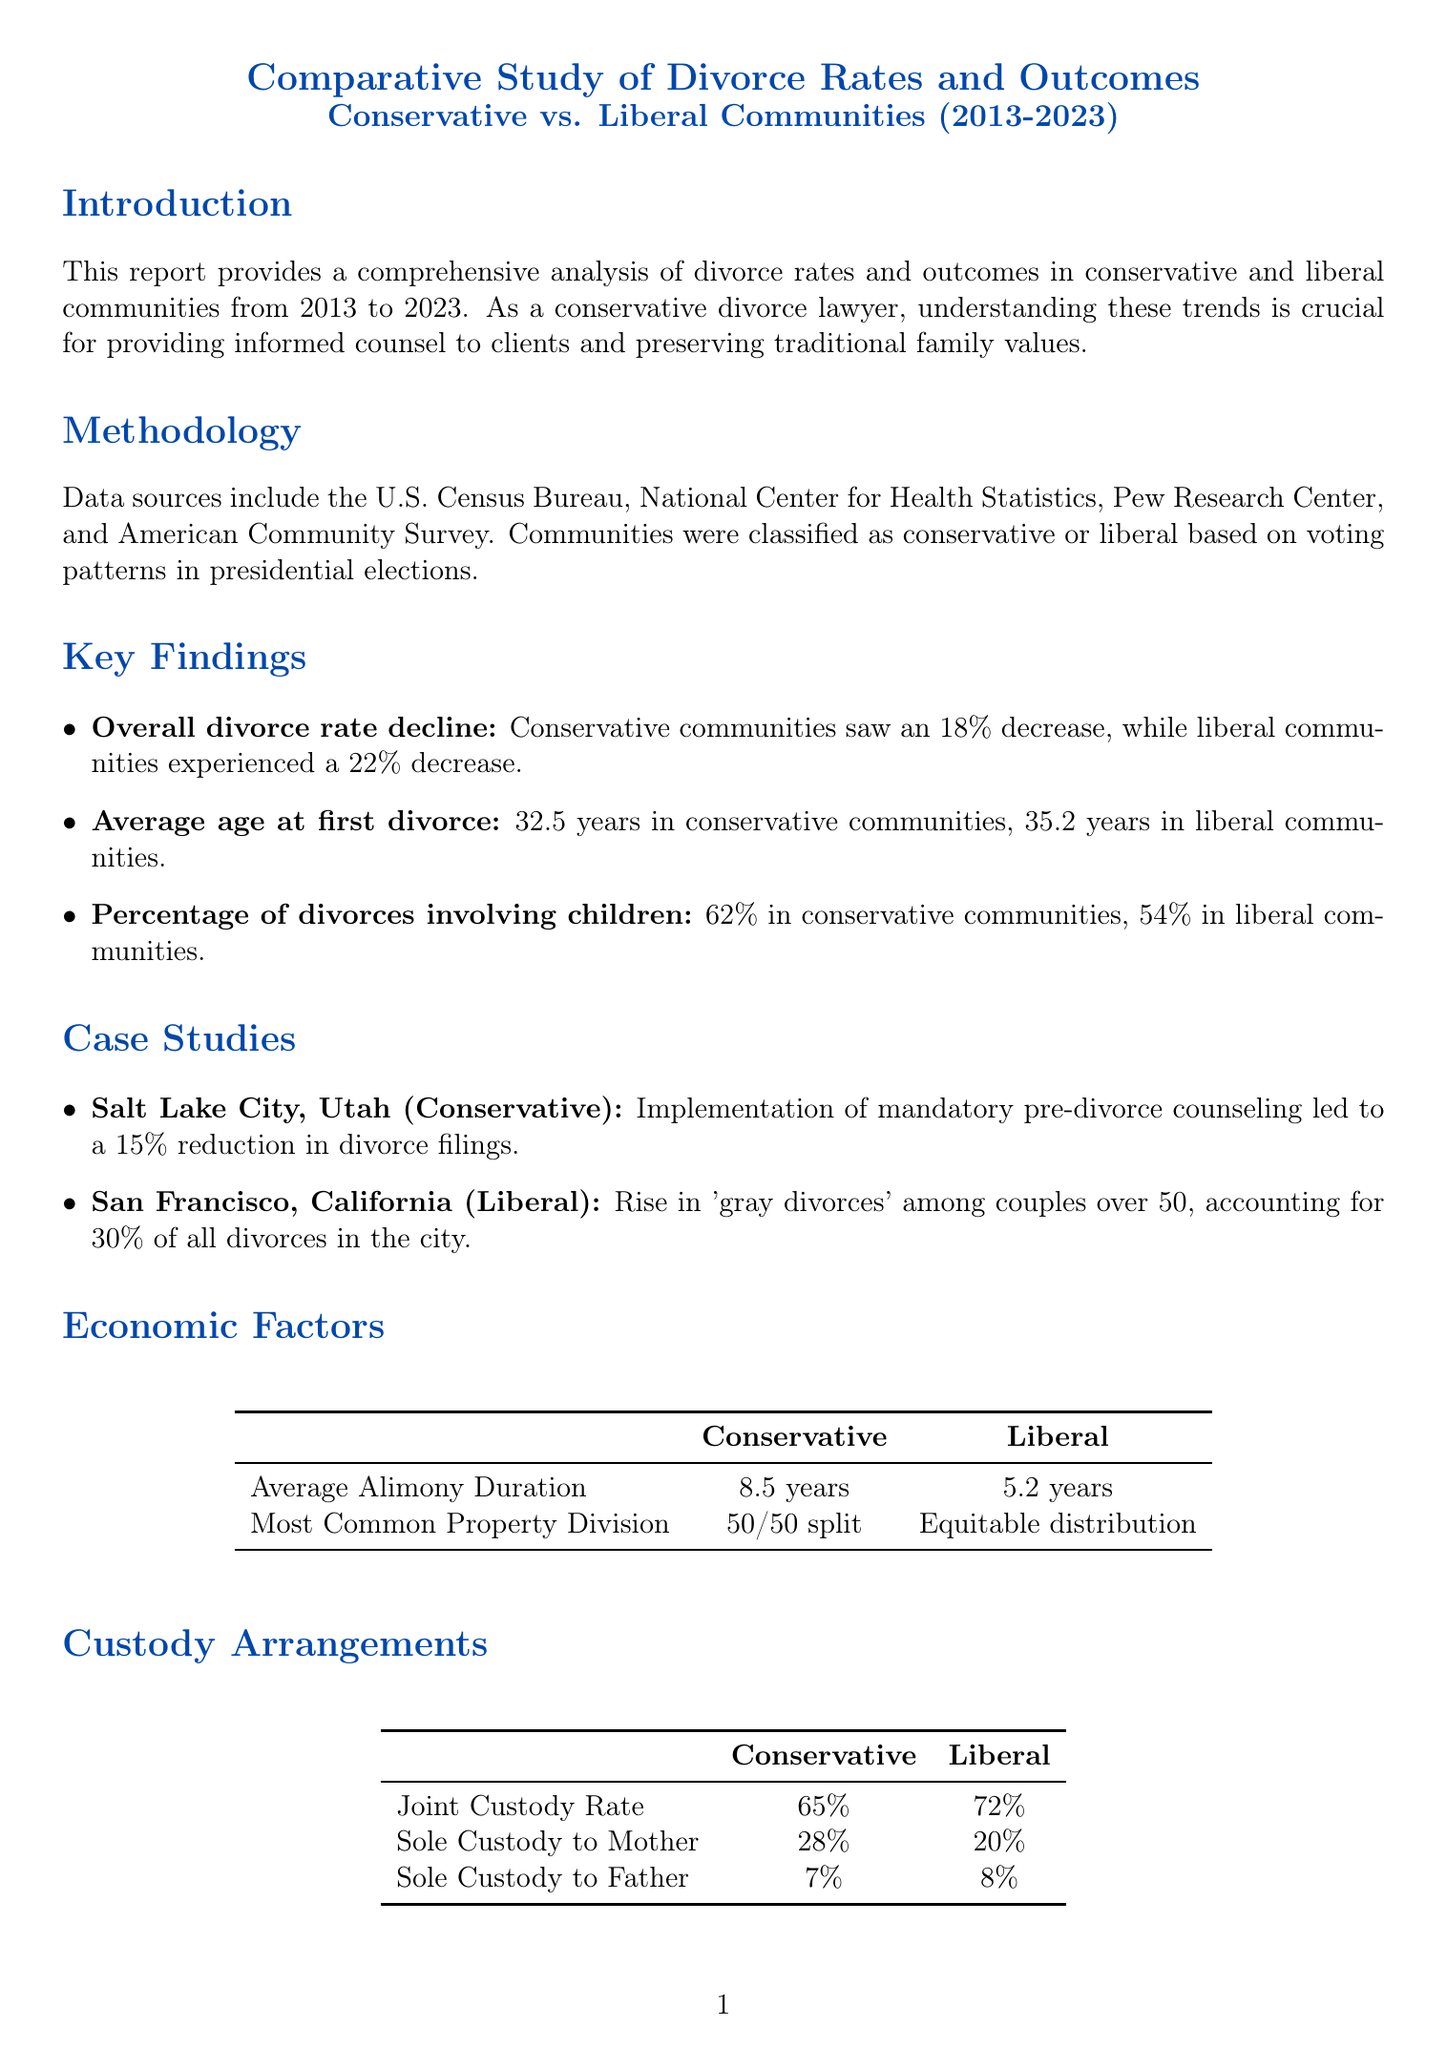what was the overall divorce rate decline in conservative communities? The report states that conservative communities saw an 18% decrease in the overall divorce rate.
Answer: 18% what is the average age at first divorce in liberal communities? The average age at first divorce in liberal communities is mentioned as 35.2 years.
Answer: 35.2 years what percentage of divorces involve children in conservative communities? The document indicates that 62% of divorces in conservative communities involve children.
Answer: 62% which community type has a higher joint custody rate? By comparing the figures provided, liberal communities have a higher joint custody rate of 72%.
Answer: Liberal what notable trend was observed in Salt Lake City, Utah? The report highlights that an implementation of mandatory pre-divorce counseling led to a 15% reduction in divorce filings in Salt Lake City.
Answer: 15% reduction how does the average alimony duration compare between conservative and liberal communities? The average alimony duration is stated as 8.5 years in conservative communities, compared to 5.2 years in liberal communities.
Answer: 8.5 years and 5.2 years what is a significant legal trend in conservative communities? The document notes an increased focus on covenant marriages as a significant legal trend in conservative communities.
Answer: Covenant marriages what is the impact of divorce on children's mental health in conservative communities? It is noted that there is a 25% increase in reported anxiety and depression among children of divorced parents in conservative communities.
Answer: 25% how do privacy considerations differ between community types? The report explains that conservative communities prefer private judges, whereas liberal communities experience increased transparency in divorce proceedings.
Answer: Private judges and transparency what implications does this study have for divorce lawyers? Understanding these trends is crucial for providing tailored legal counsel and preserving traditional family values where possible.
Answer: Tailored legal counsel and preserving traditional family values 